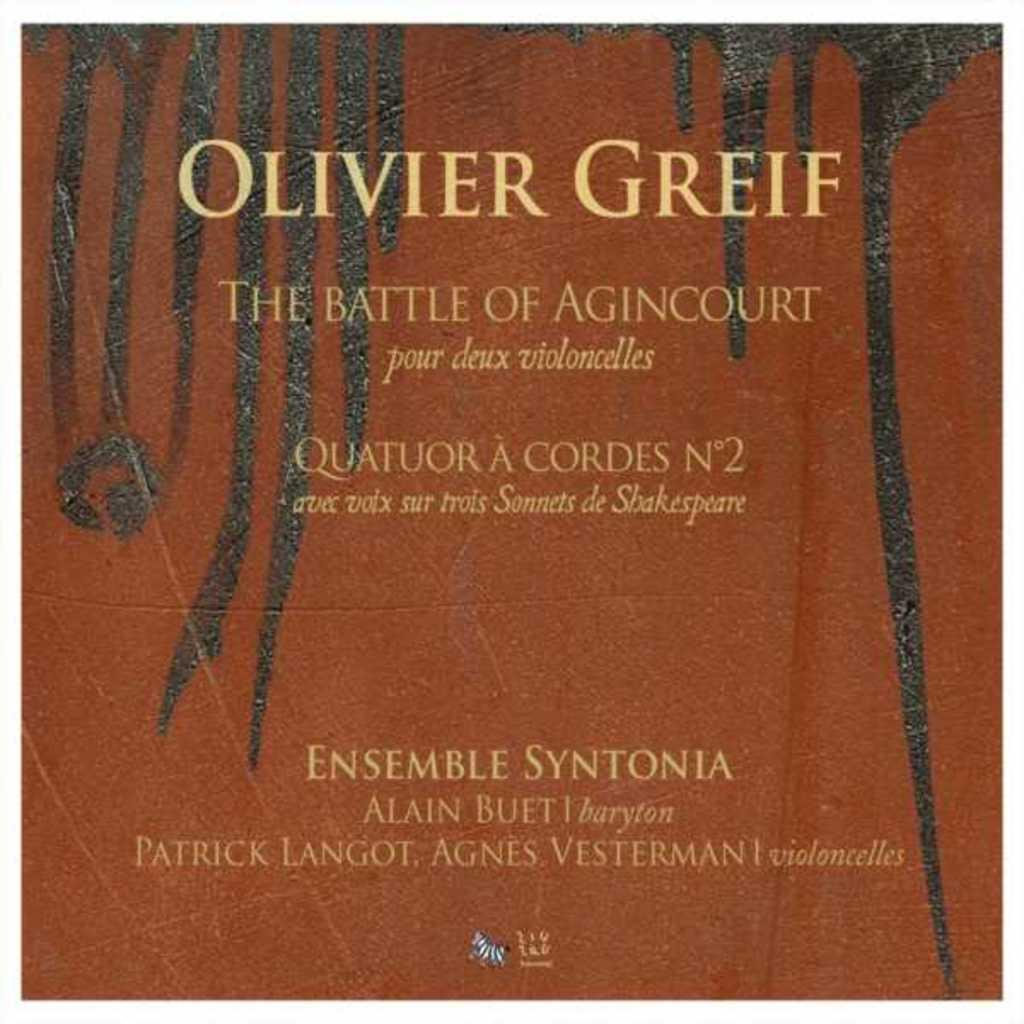Provide a one-sentence caption for the provided image. an album cover from Olivere Greif The battle of Agincourt. 